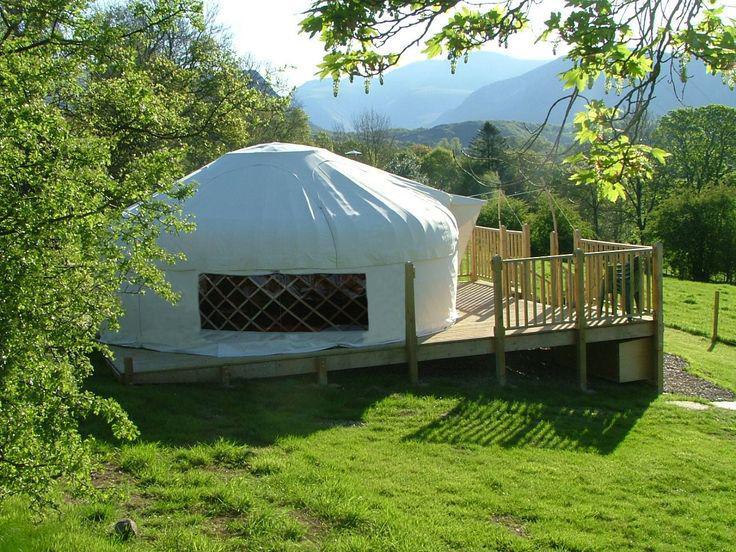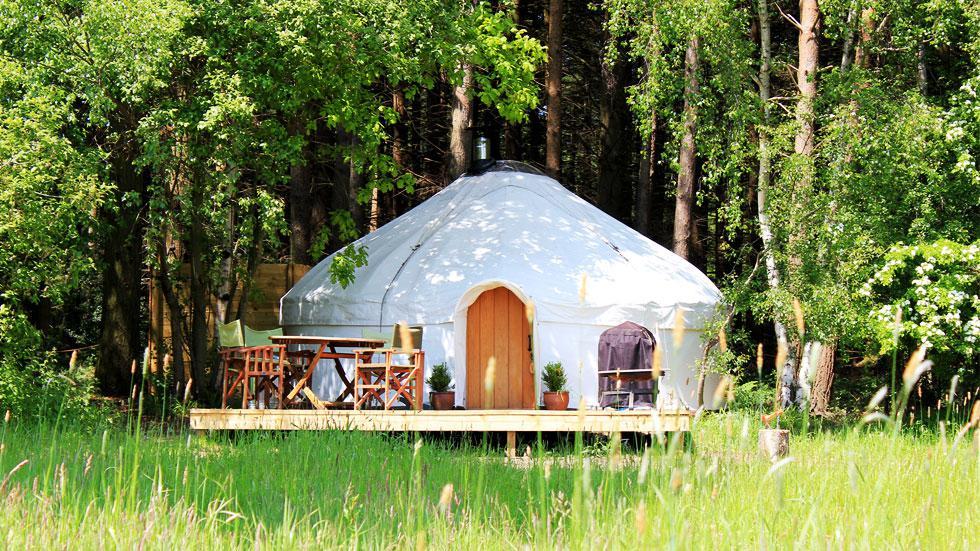The first image is the image on the left, the second image is the image on the right. Analyze the images presented: Is the assertion "The hut in the image on the right is set up on a deck." valid? Answer yes or no. Yes. The first image is the image on the left, the second image is the image on the right. For the images displayed, is the sentence "In one image, a yurt sits on a raised deck with wooden fencing, while the other image shows one or more yurts with outdoor table seating." factually correct? Answer yes or no. Yes. 